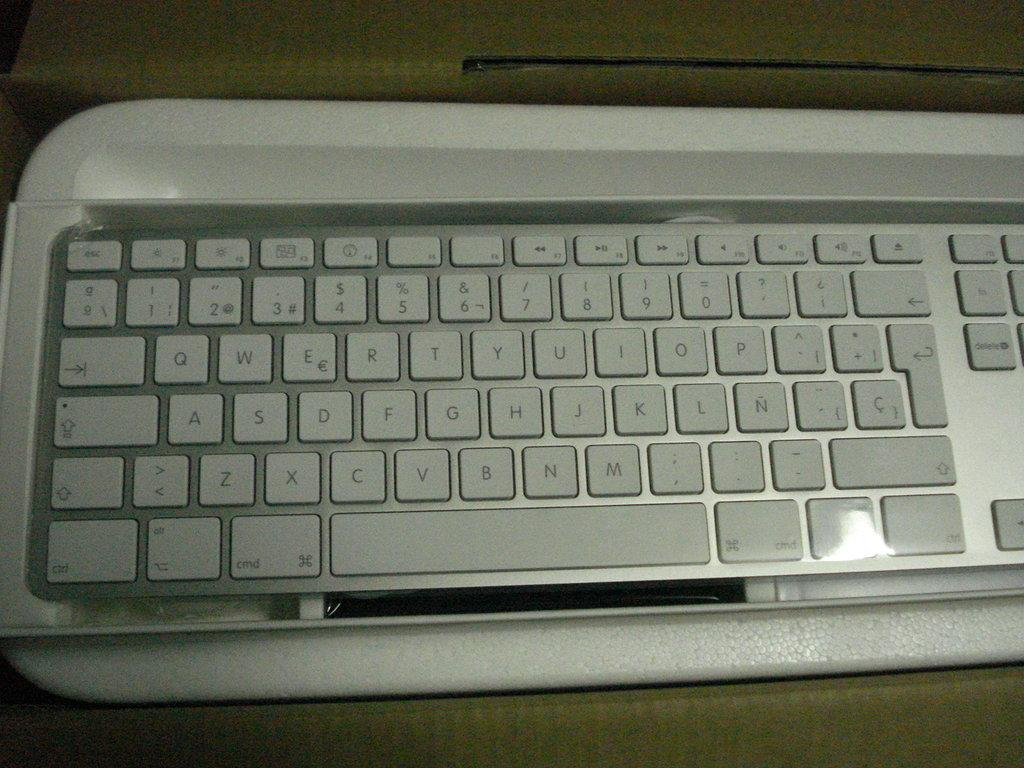<image>
Offer a succinct explanation of the picture presented. The very bottom left key on the keyboard says ctrl 